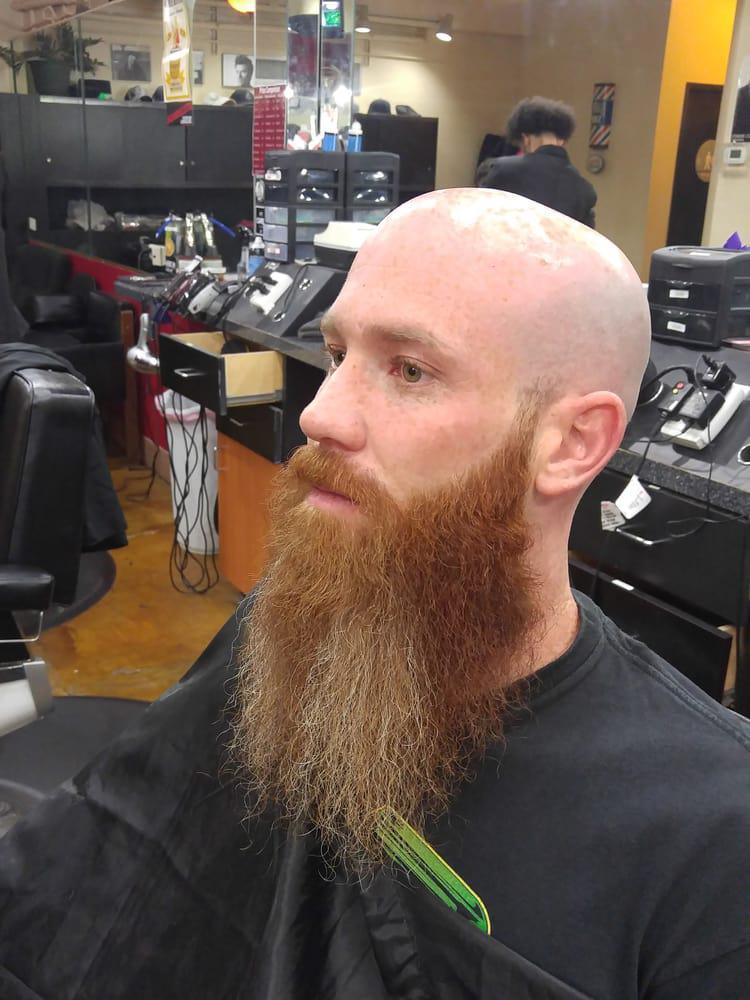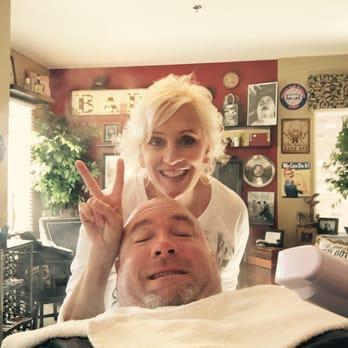The first image is the image on the left, the second image is the image on the right. Given the left and right images, does the statement "An image shows a woman with light blonde hair behind an adult male customer." hold true? Answer yes or no. Yes. 